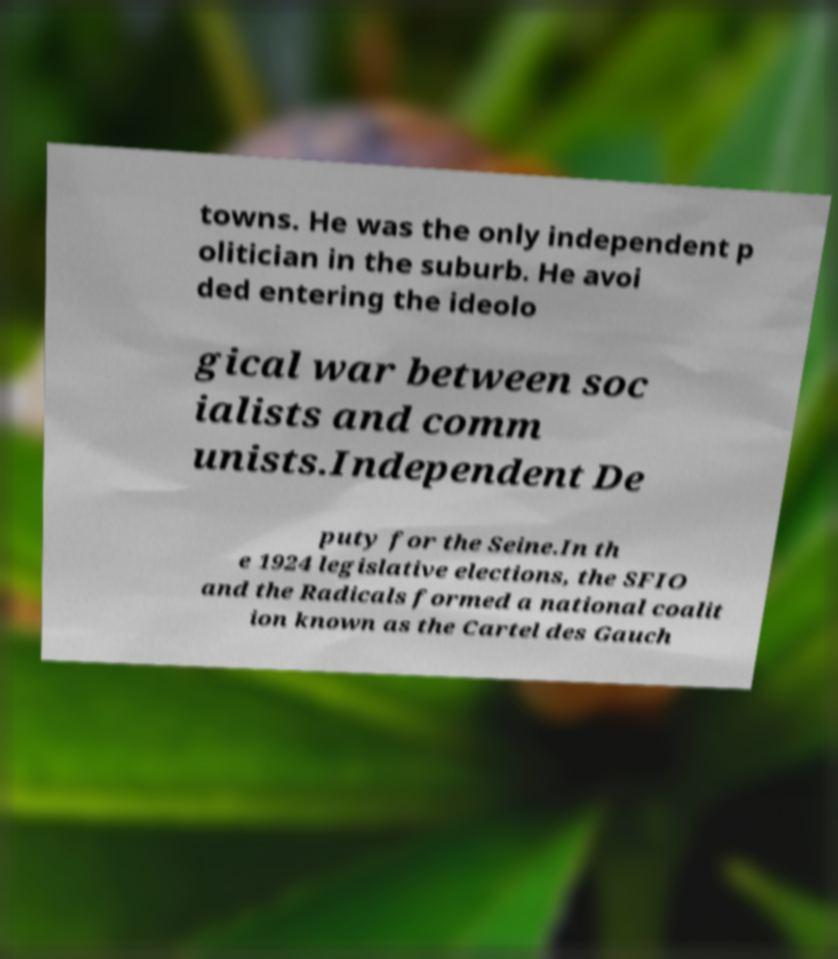Please identify and transcribe the text found in this image. towns. He was the only independent p olitician in the suburb. He avoi ded entering the ideolo gical war between soc ialists and comm unists.Independent De puty for the Seine.In th e 1924 legislative elections, the SFIO and the Radicals formed a national coalit ion known as the Cartel des Gauch 